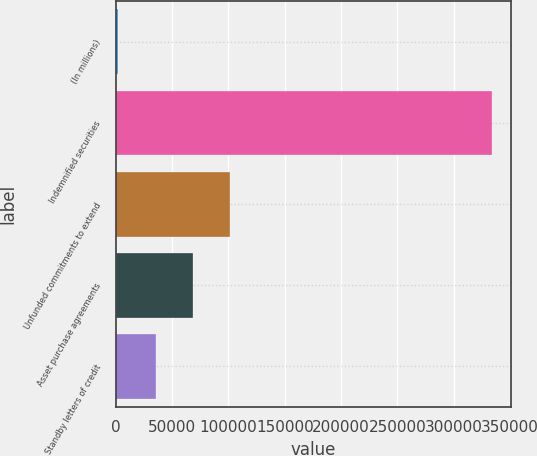Convert chart to OTSL. <chart><loc_0><loc_0><loc_500><loc_500><bar_chart><fcel>(In millions)<fcel>Indemnified securities<fcel>Unfunded commitments to extend<fcel>Asset purchase agreements<fcel>Standby letters of credit<nl><fcel>2010<fcel>334235<fcel>101678<fcel>68455<fcel>35232.5<nl></chart> 